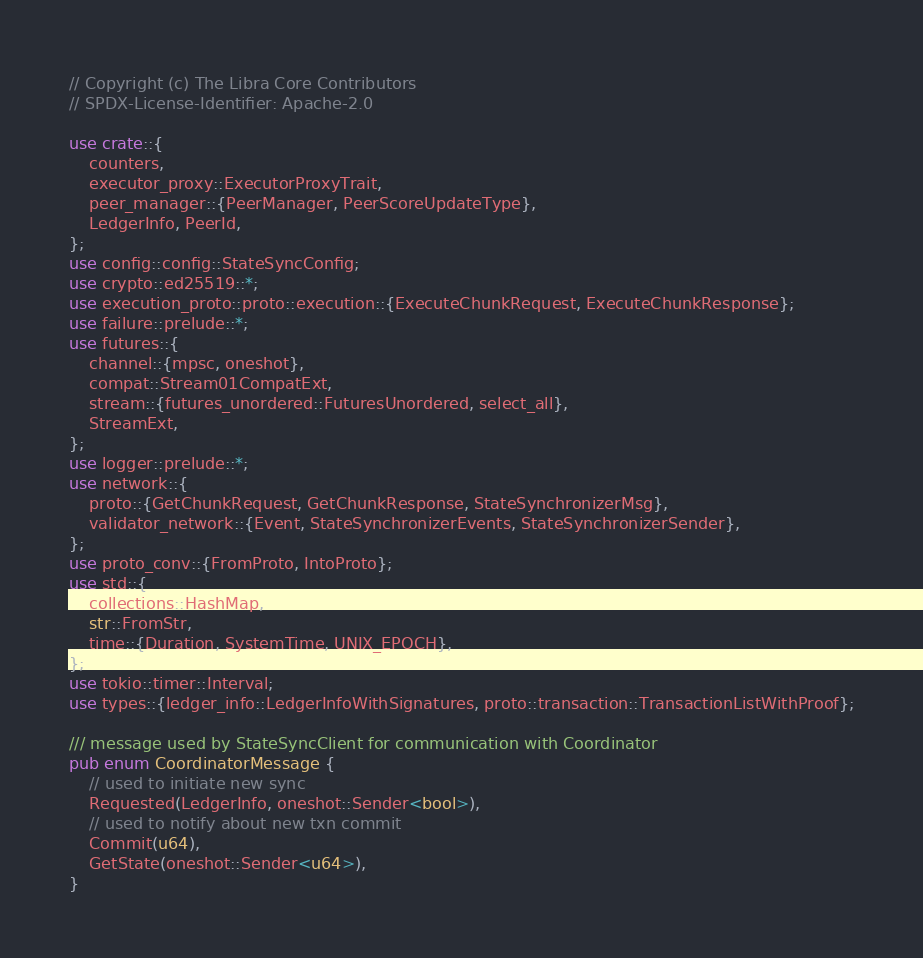<code> <loc_0><loc_0><loc_500><loc_500><_Rust_>// Copyright (c) The Libra Core Contributors
// SPDX-License-Identifier: Apache-2.0

use crate::{
    counters,
    executor_proxy::ExecutorProxyTrait,
    peer_manager::{PeerManager, PeerScoreUpdateType},
    LedgerInfo, PeerId,
};
use config::config::StateSyncConfig;
use crypto::ed25519::*;
use execution_proto::proto::execution::{ExecuteChunkRequest, ExecuteChunkResponse};
use failure::prelude::*;
use futures::{
    channel::{mpsc, oneshot},
    compat::Stream01CompatExt,
    stream::{futures_unordered::FuturesUnordered, select_all},
    StreamExt,
};
use logger::prelude::*;
use network::{
    proto::{GetChunkRequest, GetChunkResponse, StateSynchronizerMsg},
    validator_network::{Event, StateSynchronizerEvents, StateSynchronizerSender},
};
use proto_conv::{FromProto, IntoProto};
use std::{
    collections::HashMap,
    str::FromStr,
    time::{Duration, SystemTime, UNIX_EPOCH},
};
use tokio::timer::Interval;
use types::{ledger_info::LedgerInfoWithSignatures, proto::transaction::TransactionListWithProof};

/// message used by StateSyncClient for communication with Coordinator
pub enum CoordinatorMessage {
    // used to initiate new sync
    Requested(LedgerInfo, oneshot::Sender<bool>),
    // used to notify about new txn commit
    Commit(u64),
    GetState(oneshot::Sender<u64>),
}
</code> 